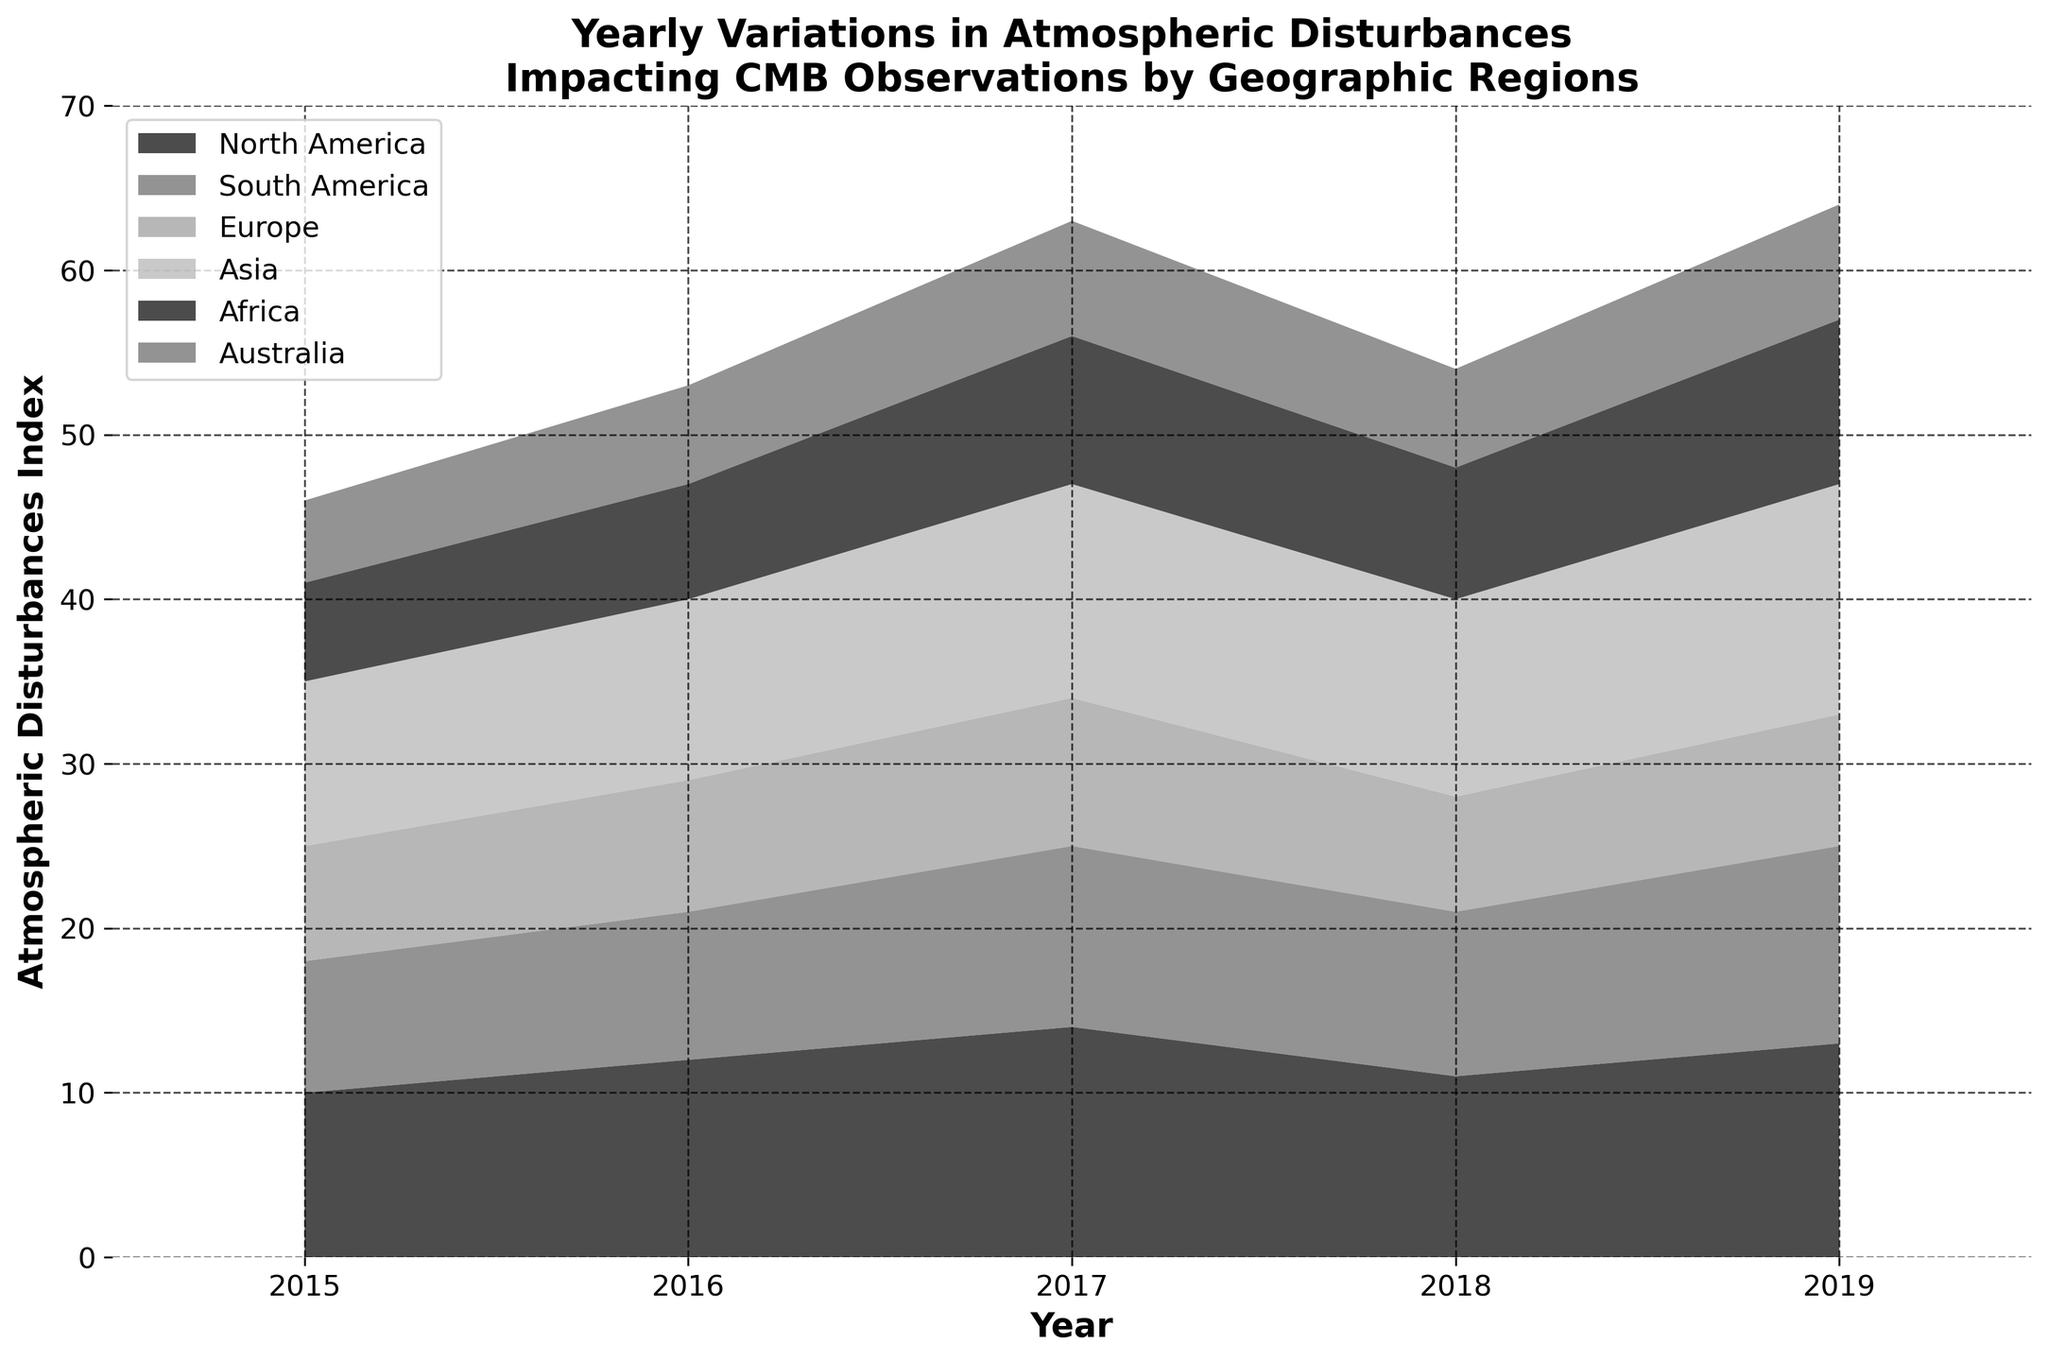What is the title of the chart? The title is usually the largest text at the top of the chart. In this figure, the title appears prominently above the plot.
Answer: Yearly Variations in Atmospheric Disturbances Impacting CMB Observations by Geographic Regions How many years are displayed on the x-axis? The x-axis labels show the range of years covered in the data. By counting the unique years labeled along the x-axis, we can determine the number of years.
Answer: 5 Which region has the highest Atmospheric Disturbances Index in 2019? Look at the individual regions and their respective areas for the year 2019. The region that extends the highest point will have the highest index for that year.
Answer: Asia Which two regions show a decrease in Atmospheric Disturbances Index from 2017 to 2018? Examine the height of the areas corresponding to each region for the years 2017 and 2018 and identify any decreases.
Answer: North America, Africa Which region consistently shows the lowest index from 2015 to 2019? Identify the region that has the smallest area summed over all the years, indicating the lowest index consistently.
Answer: Australia What is the combined Atmospheric Disturbances Index for all regions in 2017? Sum the indices for all regions for the year 2017 by adding the heights of the respective areas at that year. Explanation: North America (14) + South America (11) + Europe (9) + Asia (13) + Africa (9) + Australia (7) = 63
Answer: 63 Between which years did South America experience its highest increase in the Atmospheric Disturbances Index? Look for the largest vertical increase in the area representing South America from one year to the next.
Answer: 2017 to 2019 What trend can be observed for the Atmospheric Disturbances Index in Europe from 2015 to 2019? Examine the area representing Europe over the years and describe the overall pattern.
Answer: Relatively stable, with a slight increase and decrease How does the total Atmospheric Disturbances Index in 2018 compare to 2016? Sum the individual region indices for 2016 and 2018, then compare the totals. Explanation: 2016: (12 + 9 + 8 + 11 + 7 + 6) = 53, 2018: (11 + 10 + 7 + 12 + 8 + 6) = 54. The total index slightly increased from 2016 to 2018.
Answer: Increased by 1 